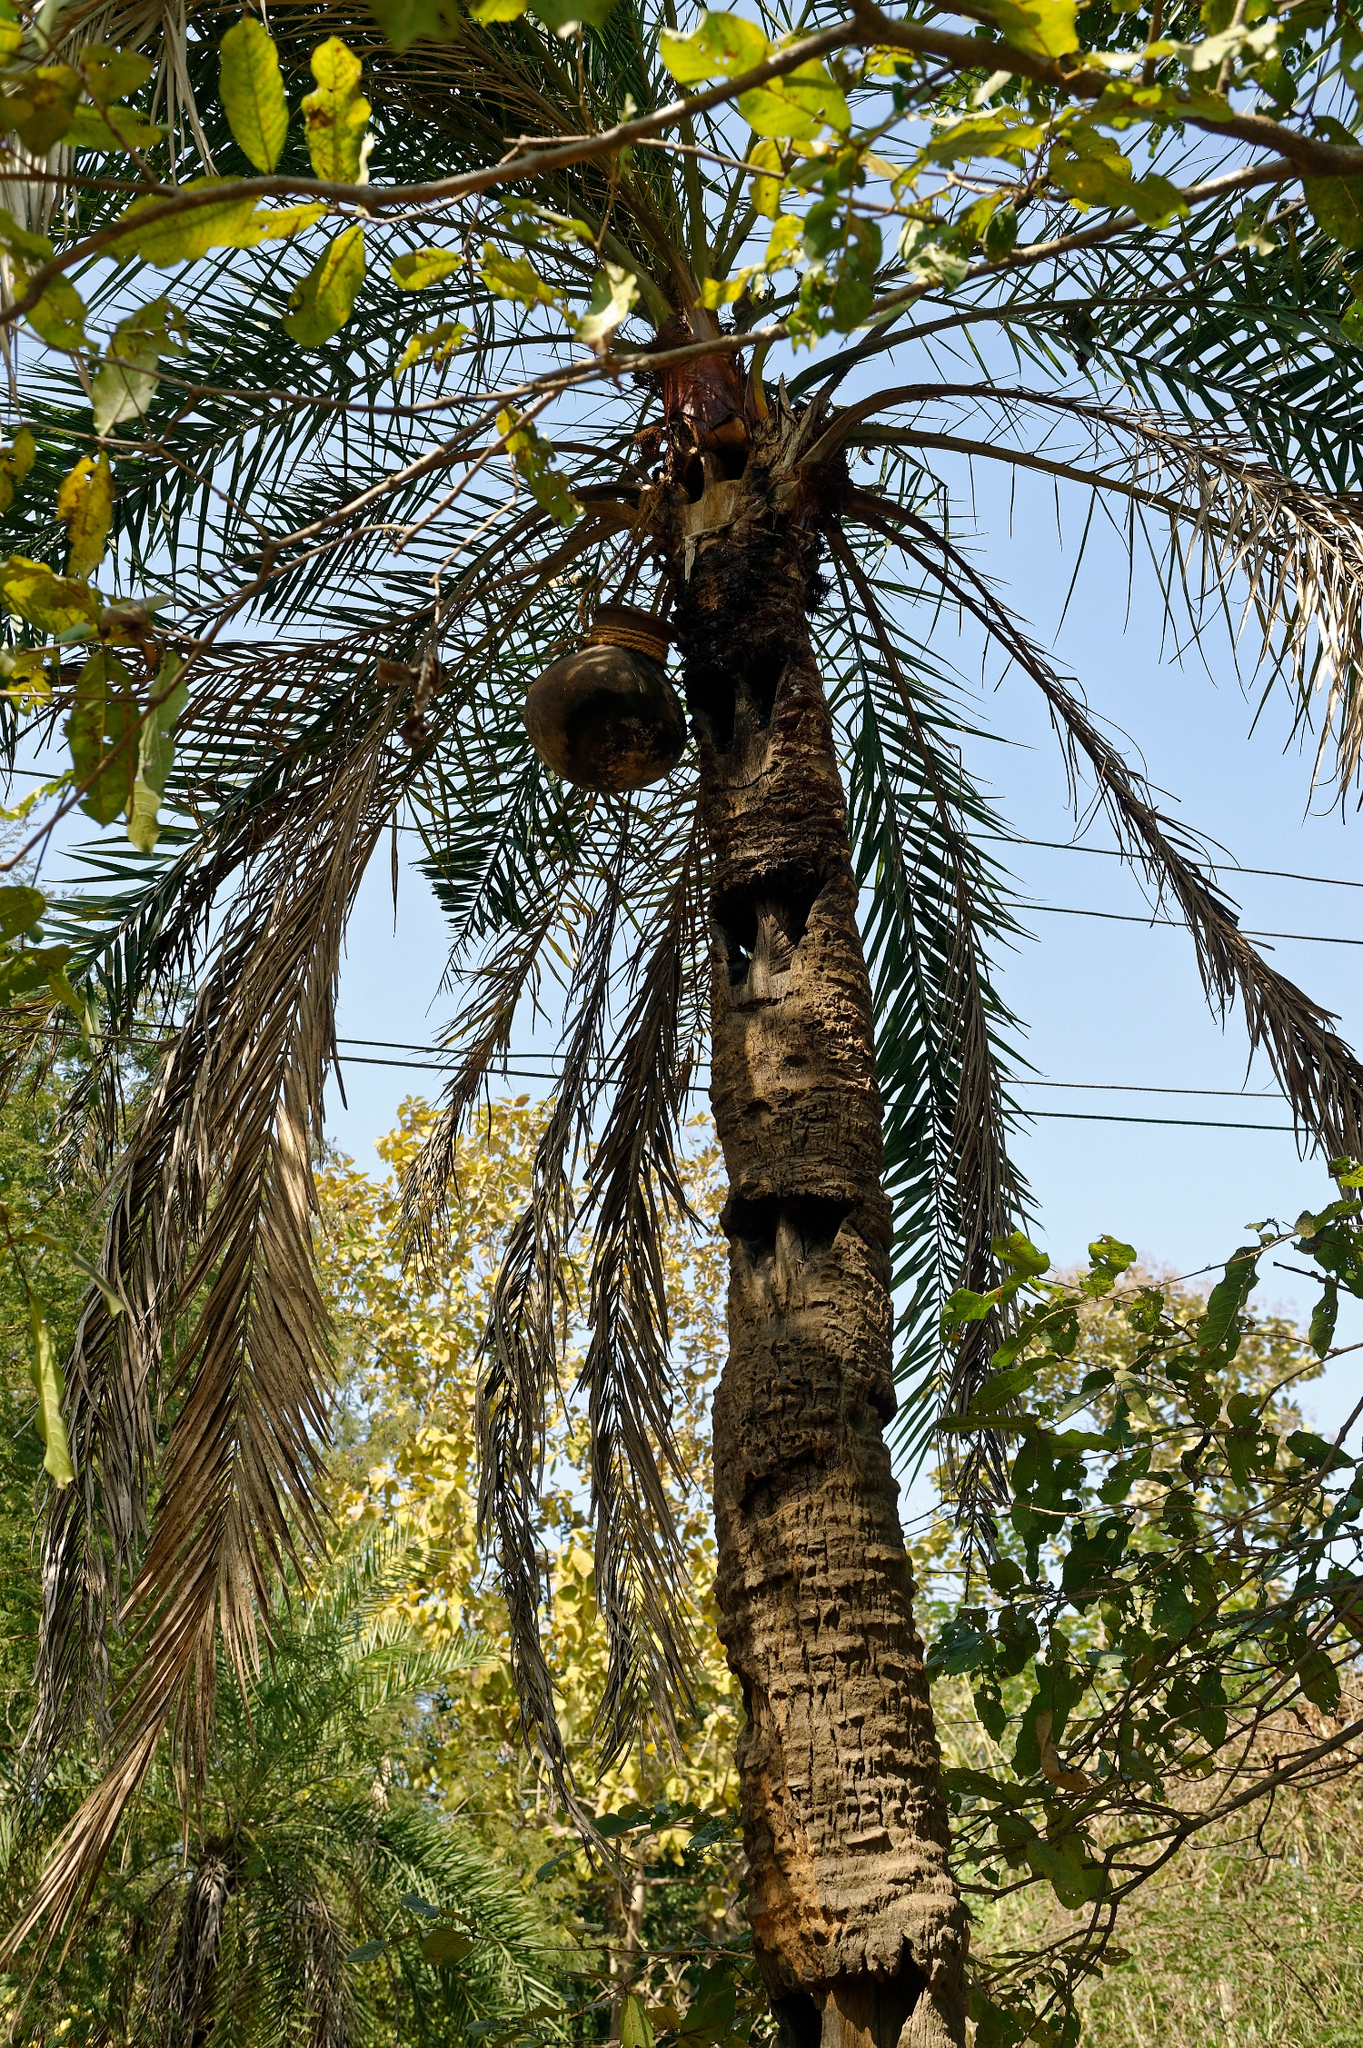Imagine if the birdhouse had magical properties. What magical events might occur around this palm tree? If the birdhouse had magical properties, nights around the palm tree would transform into enchanting spectacles. As dusk settles, the birdhouse would start to emit a gentle, golden glow, attracting fireflies that dance in spiraling patterns around the tree. Birds that perch here gain the ability to sing songs that make flowers bloom and heal wounded creatures with their melody. On the full moon nights, the glow grows brighter, and haloed reflections emanate from the birdhouse, creating a mirage of an untouched paradise. The tree's leaves would shimmer with every note, and the forest animals would gather around to be part of this magic, feeling the air thickening with wonder and awe. It’s as if, for those brief magical moments, the tree and its surroundings are enveloped in a celestial embrace, turning the ordinary into the extraordinary. 